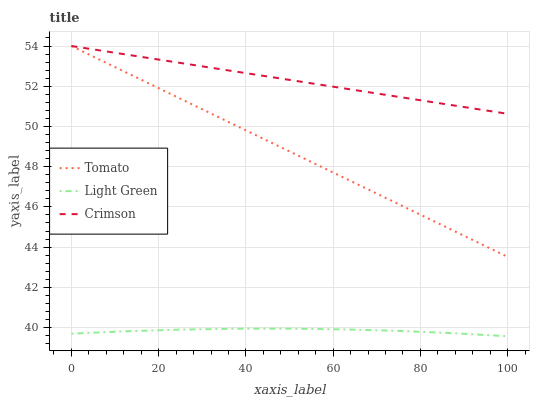Does Light Green have the minimum area under the curve?
Answer yes or no. Yes. Does Crimson have the maximum area under the curve?
Answer yes or no. Yes. Does Crimson have the minimum area under the curve?
Answer yes or no. No. Does Light Green have the maximum area under the curve?
Answer yes or no. No. Is Crimson the smoothest?
Answer yes or no. Yes. Is Light Green the roughest?
Answer yes or no. Yes. Is Light Green the smoothest?
Answer yes or no. No. Is Crimson the roughest?
Answer yes or no. No. Does Light Green have the lowest value?
Answer yes or no. Yes. Does Crimson have the lowest value?
Answer yes or no. No. Does Crimson have the highest value?
Answer yes or no. Yes. Does Light Green have the highest value?
Answer yes or no. No. Is Light Green less than Crimson?
Answer yes or no. Yes. Is Crimson greater than Light Green?
Answer yes or no. Yes. Does Crimson intersect Tomato?
Answer yes or no. Yes. Is Crimson less than Tomato?
Answer yes or no. No. Is Crimson greater than Tomato?
Answer yes or no. No. Does Light Green intersect Crimson?
Answer yes or no. No. 